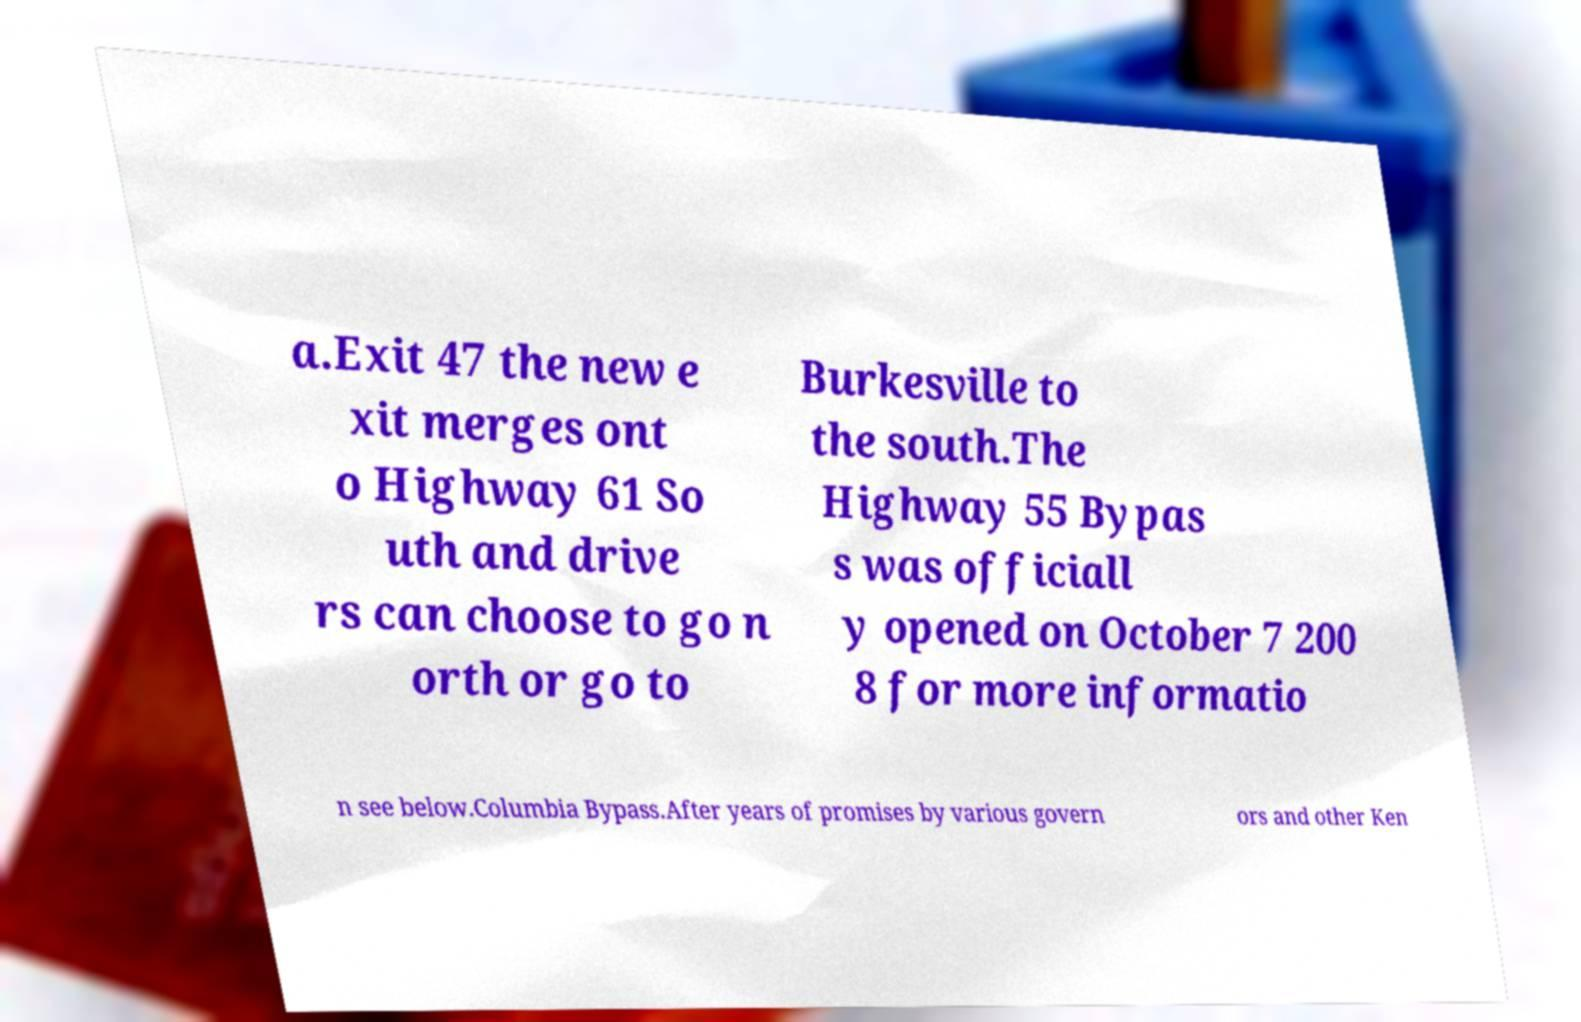Please read and relay the text visible in this image. What does it say? a.Exit 47 the new e xit merges ont o Highway 61 So uth and drive rs can choose to go n orth or go to Burkesville to the south.The Highway 55 Bypas s was officiall y opened on October 7 200 8 for more informatio n see below.Columbia Bypass.After years of promises by various govern ors and other Ken 